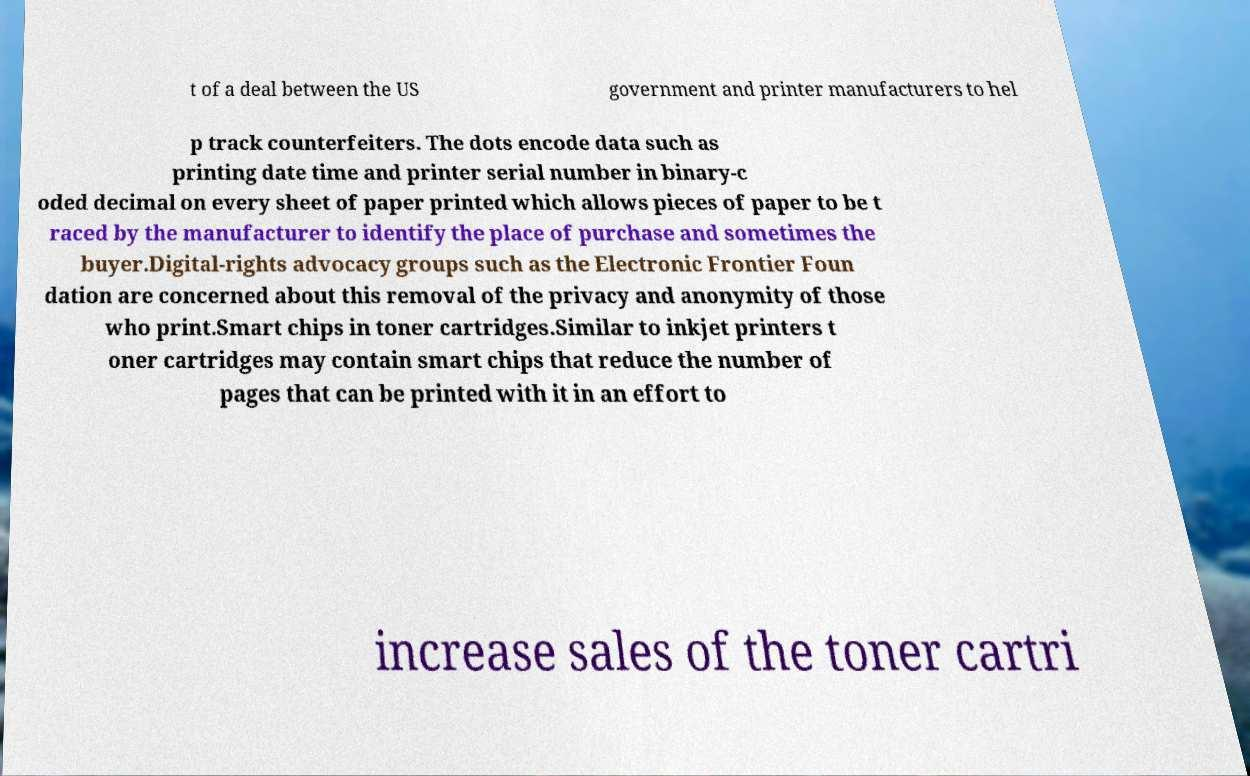Please read and relay the text visible in this image. What does it say? t of a deal between the US government and printer manufacturers to hel p track counterfeiters. The dots encode data such as printing date time and printer serial number in binary-c oded decimal on every sheet of paper printed which allows pieces of paper to be t raced by the manufacturer to identify the place of purchase and sometimes the buyer.Digital-rights advocacy groups such as the Electronic Frontier Foun dation are concerned about this removal of the privacy and anonymity of those who print.Smart chips in toner cartridges.Similar to inkjet printers t oner cartridges may contain smart chips that reduce the number of pages that can be printed with it in an effort to increase sales of the toner cartri 